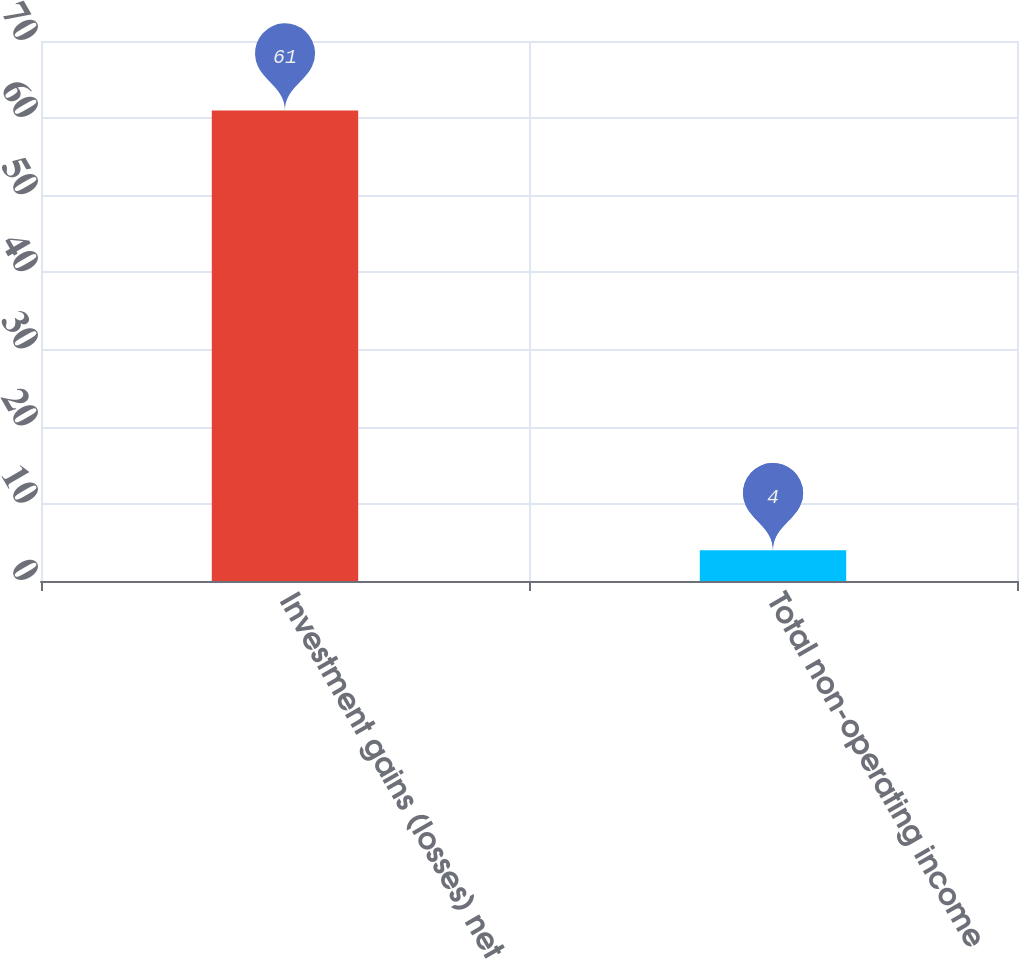<chart> <loc_0><loc_0><loc_500><loc_500><bar_chart><fcel>Investment gains (losses) net<fcel>Total non-operating income<nl><fcel>61<fcel>4<nl></chart> 